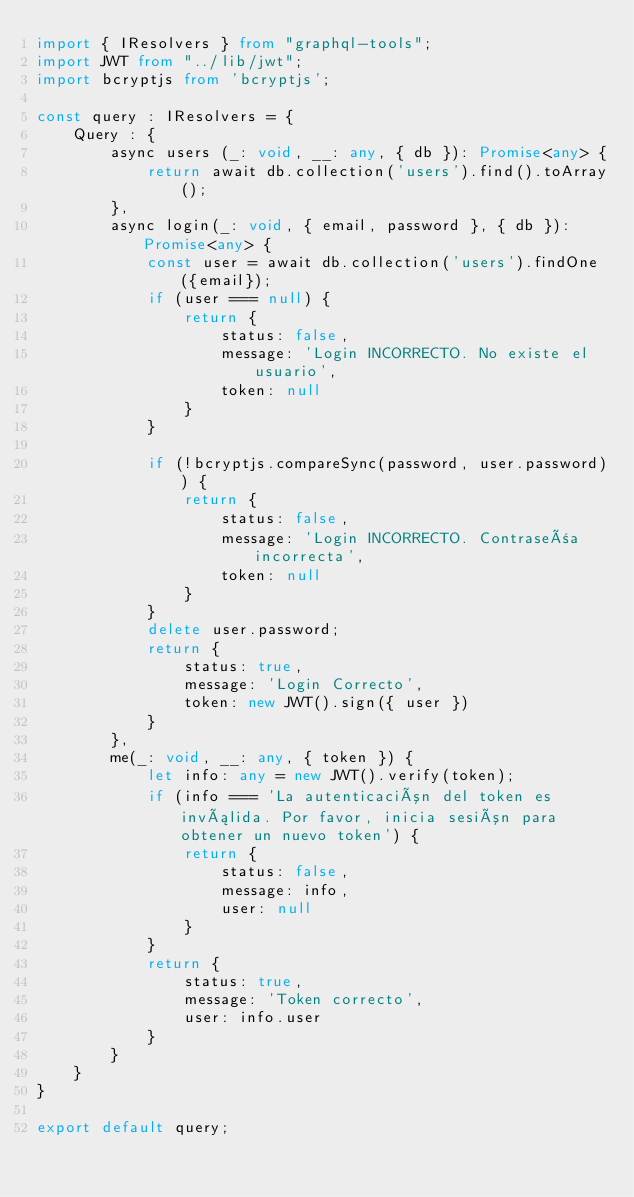<code> <loc_0><loc_0><loc_500><loc_500><_TypeScript_>import { IResolvers } from "graphql-tools";
import JWT from "../lib/jwt";
import bcryptjs from 'bcryptjs';

const query : IResolvers = {
    Query : {
        async users (_: void, __: any, { db }): Promise<any> {
            return await db.collection('users').find().toArray();
        },
        async login(_: void, { email, password }, { db }): Promise<any> {
            const user = await db.collection('users').findOne({email});
            if (user === null) {
                return {
                    status: false,
                    message: 'Login INCORRECTO. No existe el usuario',
                    token: null
                }
            }

            if (!bcryptjs.compareSync(password, user.password)) {
                return {
                    status: false,
                    message: 'Login INCORRECTO. Contraseña incorrecta',
                    token: null
                }
            }
            delete user.password;
            return {
                status: true,
                message: 'Login Correcto',
                token: new JWT().sign({ user })
            }
        },
        me(_: void, __: any, { token }) {
            let info: any = new JWT().verify(token);
            if (info === 'La autenticación del token es inválida. Por favor, inicia sesión para obtener un nuevo token') {
                return {
                    status: false,
                    message: info,
                    user: null
                }
            }
            return {
                status: true,
                message: 'Token correcto',
                user: info.user
            }
        }
    }
}

export default query;</code> 